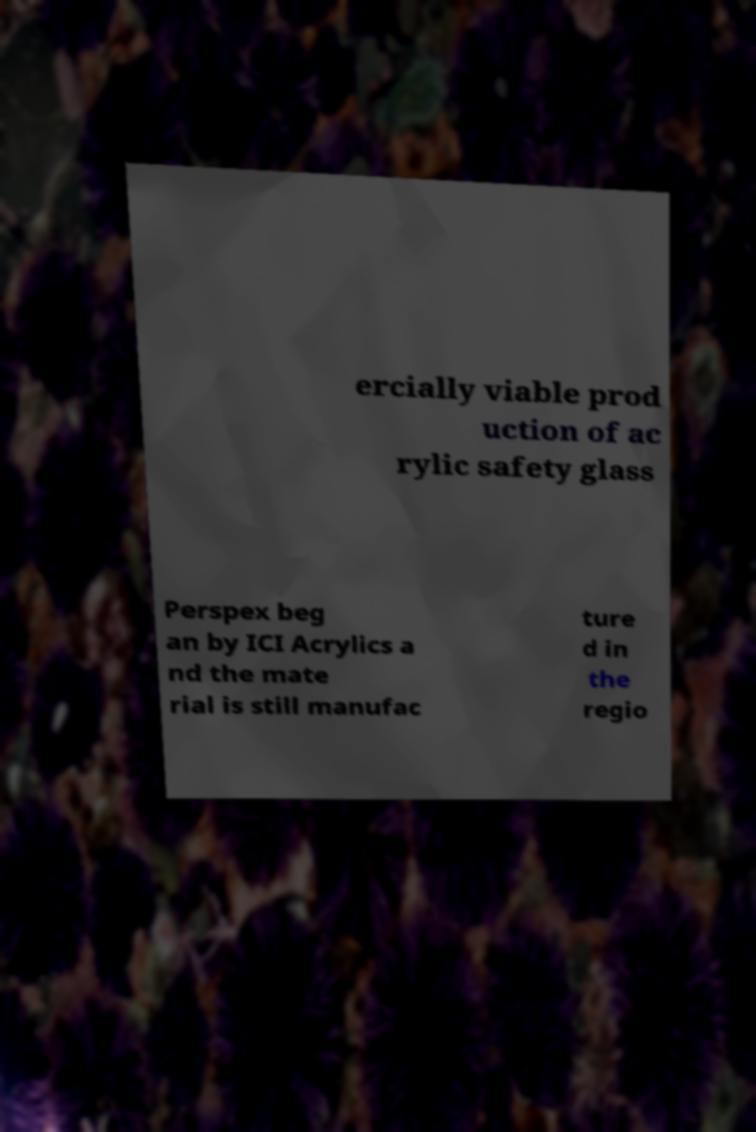Could you assist in decoding the text presented in this image and type it out clearly? ercially viable prod uction of ac rylic safety glass Perspex beg an by ICI Acrylics a nd the mate rial is still manufac ture d in the regio 